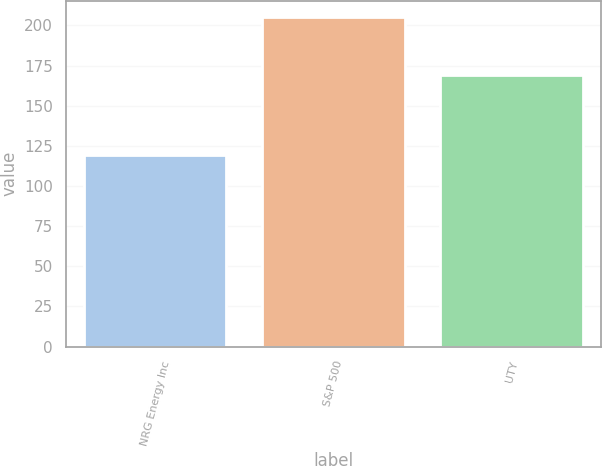<chart> <loc_0><loc_0><loc_500><loc_500><bar_chart><fcel>NRG Energy Inc<fcel>S&P 500<fcel>UTY<nl><fcel>119.18<fcel>205.14<fcel>168.85<nl></chart> 